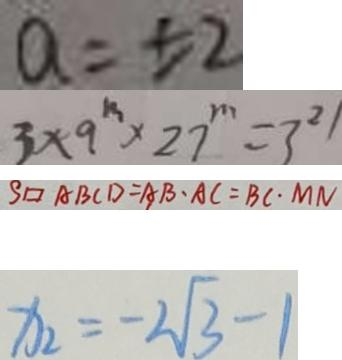<formula> <loc_0><loc_0><loc_500><loc_500>a = \pm 2 
 3 \times 9 ^ { m } \times 2 7 ^ { m } = 3 ^ { 2 1 } 
 S \square A B C D = A B \cdot A C = B C \cdot M N 
 x _ { 2 } = - 2 \sqrt { 3 } - 1</formula> 